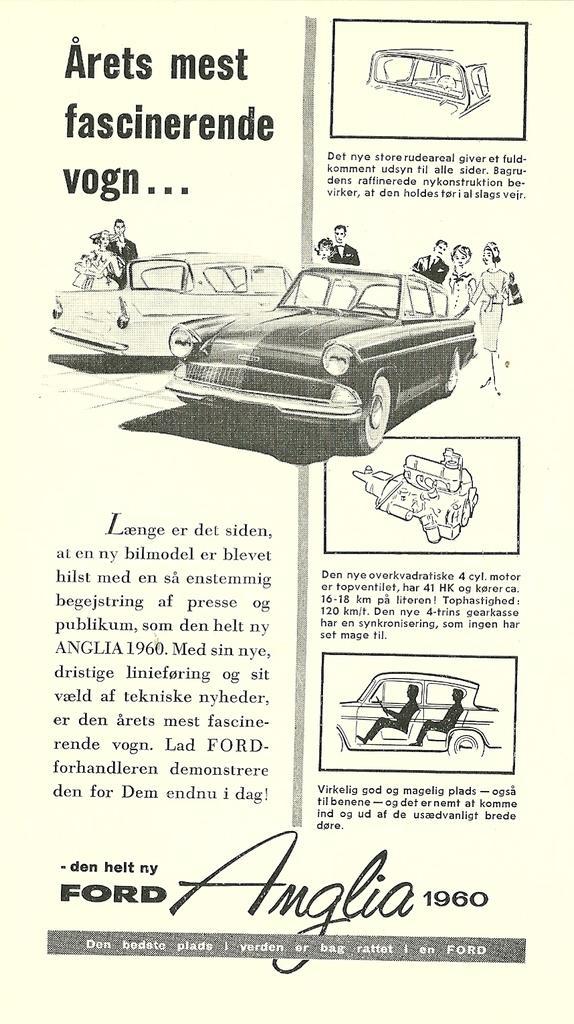Describe this image in one or two sentences. In this image I can see some line art of a car spare parts and depictions and drawings of people with cars with some text.  